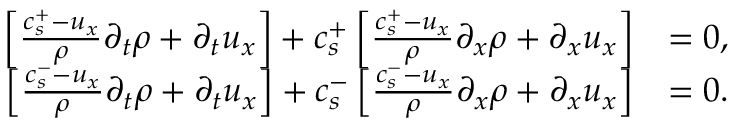<formula> <loc_0><loc_0><loc_500><loc_500>\begin{array} { r l } { \left [ \frac { c _ { s } ^ { + } - u _ { x } } { \rho } \partial _ { t } \rho + \partial _ { t } u _ { x } \right ] + c _ { s } ^ { + } \left [ \frac { c _ { s } ^ { + } - u _ { x } } { \rho } \partial _ { x } \rho + \partial _ { x } u _ { x } \right ] } & { = 0 , } \\ { \left [ \frac { c _ { s } ^ { - } - u _ { x } } { \rho } \partial _ { t } \rho + \partial _ { t } u _ { x } \right ] + c _ { s } ^ { - } \left [ \frac { c _ { s } ^ { - } - u _ { x } } { \rho } \partial _ { x } \rho + \partial _ { x } u _ { x } \right ] } & { = 0 . } \end{array}</formula> 